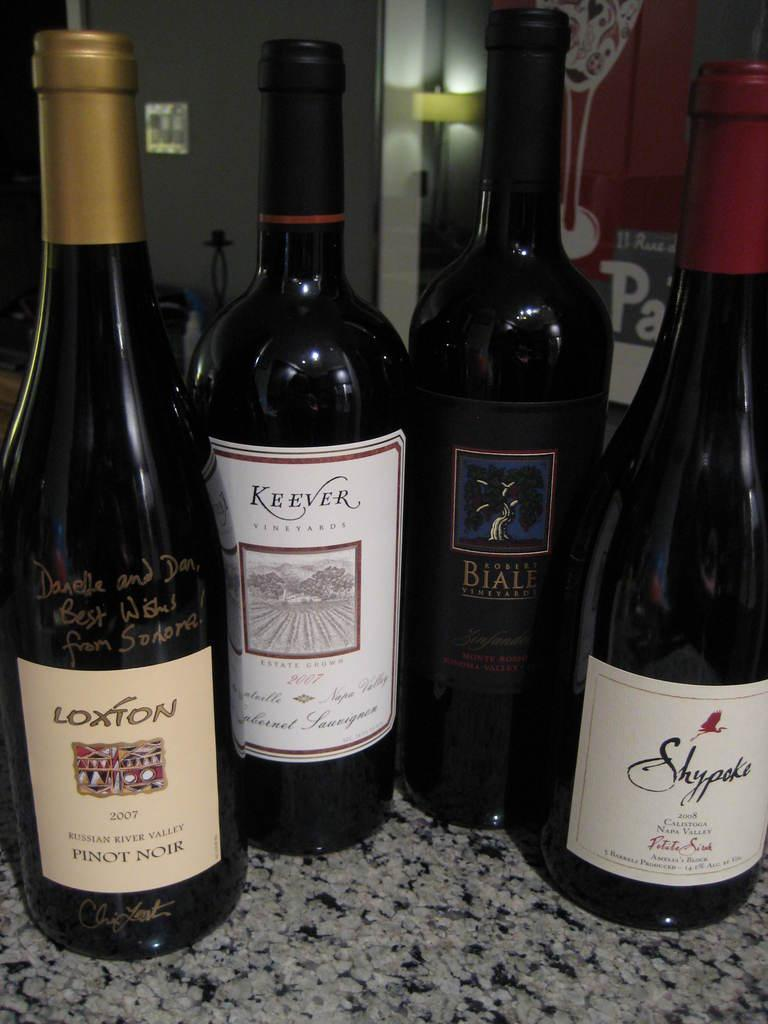<image>
Give a short and clear explanation of the subsequent image. Four bottles of wine lie on a counter including a Loxton bottle. 